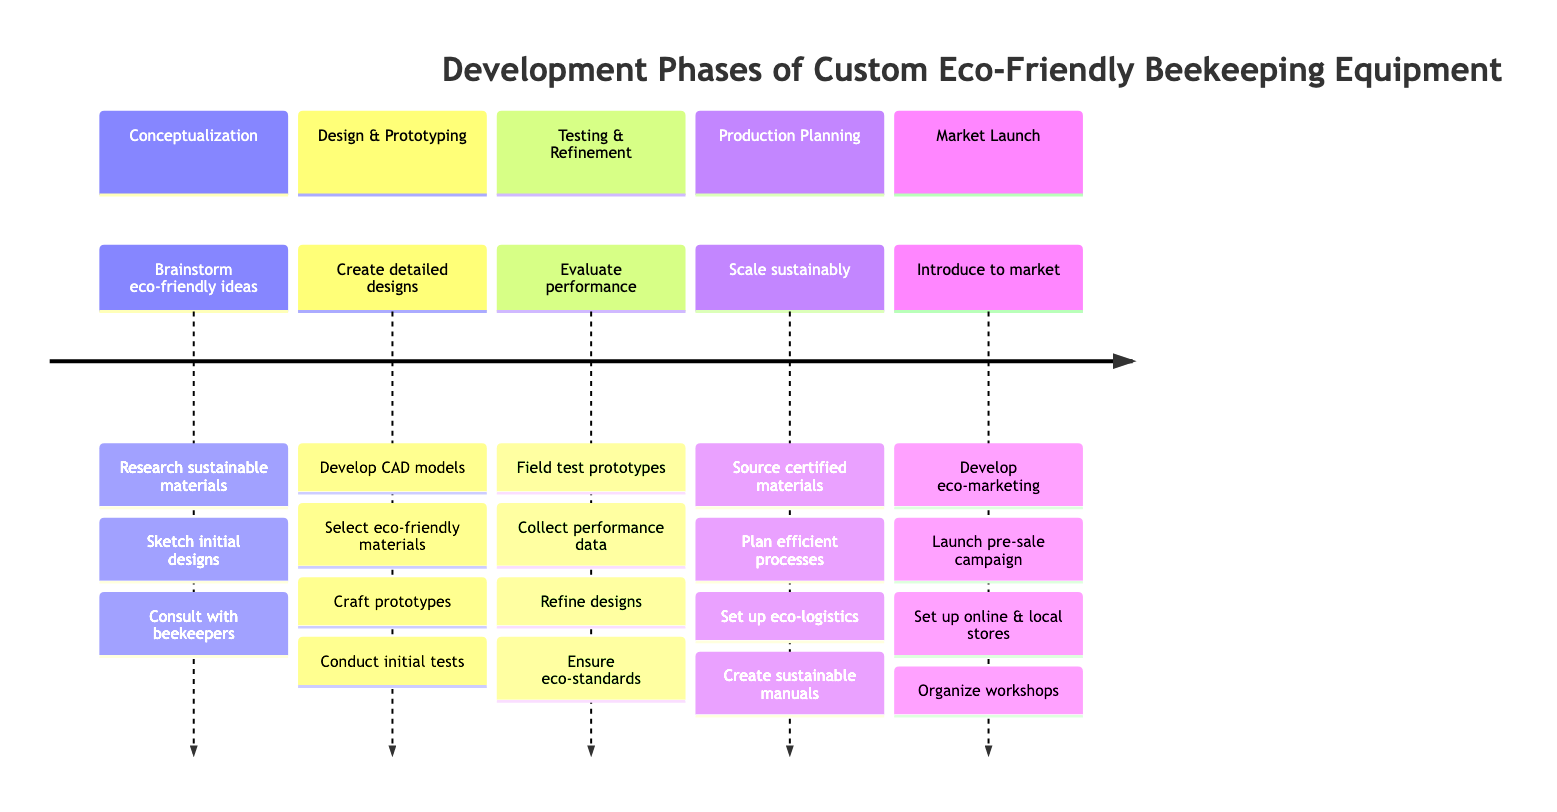What's the first phase in the development timeline? The timeline's first section lists "Conceptualization" as the initial phase.
Answer: Conceptualization How many tasks are listed under the "Design & Prototyping" phase? The "Design & Prototyping" phase includes four tasks as detailed in the section.
Answer: Four What is the main focus of the "Testing & Refinement" phase? The primary focus of this phase is to "Evaluate product performance and make necessary adjustments" as stated in the description.
Answer: Evaluate performance Which section includes "Sourcing sustainable materials from certified suppliers"? This task is included under the "Production Planning" section, which focuses on scaling sustainably.
Answer: Production Planning What phase comes directly after "Design & Prototyping"? The phase that follows "Design & Prototyping" in the timeline is "Testing & Refinement".
Answer: Testing & Refinement How many total phases are there in the timeline? The timeline comprises five distinct phases, as outlined in the sections.
Answer: Five What is one of the tasks listed under the "Market Launch" phase? One of the tasks includes "Developing marketing materials highlighting eco-friendly aspects" which is part of the Market Launch phase.
Answer: Developing marketing materials Which task mentions checking the safety for bees? The task related to ensuring bee safety is "Collecting data on product performance, durability, and bee safety" under the "Testing & Refinement" phase.
Answer: Collecting data on product performance, durability, and bee safety What section does the task "Set up eco-logistics" belong to? This task is part of the "Production Planning" section, focusing on scaling production sustainably.
Answer: Production Planning 